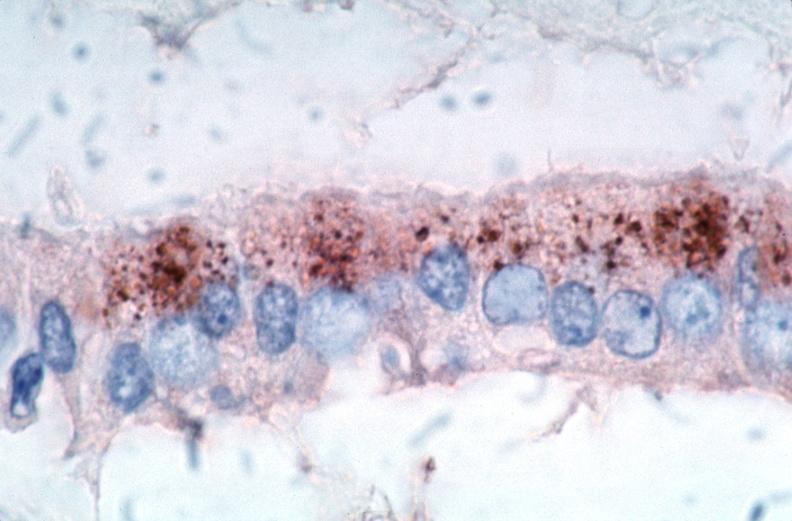what is rocky mountain spotted?
Answer the question using a single word or phrase. Fever 